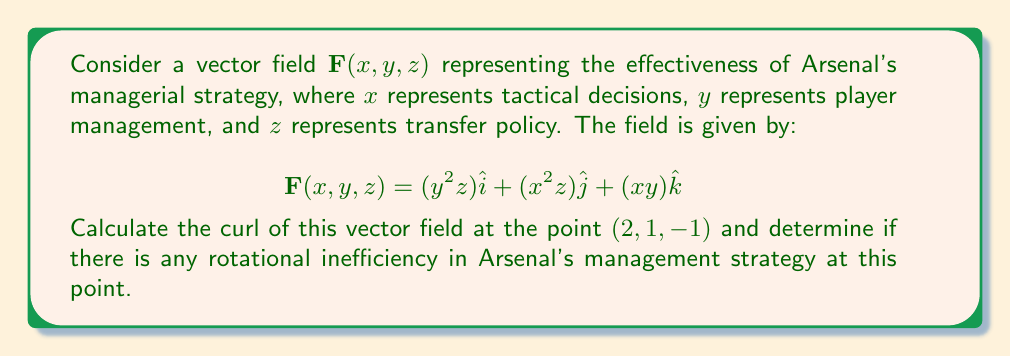Provide a solution to this math problem. To analyze the curl of the vector field, we need to follow these steps:

1) The curl of a vector field $\mathbf{F}(x, y, z) = P\hat{i} + Q\hat{j} + R\hat{k}$ is given by:

   $$\text{curl }\mathbf{F} = \nabla \times \mathbf{F} = \left(\frac{\partial R}{\partial y} - \frac{\partial Q}{\partial z}\right)\hat{i} + \left(\frac{\partial P}{\partial z} - \frac{\partial R}{\partial x}\right)\hat{j} + \left(\frac{\partial Q}{\partial x} - \frac{\partial P}{\partial y}\right)\hat{k}$$

2) For our vector field:
   $P = y^2z$, $Q = x^2z$, $R = xy$

3) Let's calculate each component:

   $\frac{\partial R}{\partial y} = x$
   $\frac{\partial Q}{\partial z} = x^2$
   $\frac{\partial P}{\partial z} = y^2$
   $\frac{\partial R}{\partial x} = y$
   $\frac{\partial Q}{\partial x} = 2xz$
   $\frac{\partial P}{\partial y} = 2yz$

4) Substituting into the curl formula:

   $$\text{curl }\mathbf{F} = (x - x^2)\hat{i} + (y^2 - y)\hat{j} + (2xz - 2yz)\hat{k}$$

5) Evaluating at the point $(2, 1, -1)$:

   $$\text{curl }\mathbf{F}(2, 1, -1) = (2 - 4)\hat{i} + (1 - 1)\hat{j} + (2(2)(-1) - 2(1)(-1))\hat{k}$$
   
   $$= -2\hat{i} + 0\hat{j} + 0\hat{k}$$

6) The non-zero curl indicates there is rotational inefficiency in Arsenal's management strategy at this point, particularly in the $x$ (tactical decisions) direction.
Answer: $-2\hat{i}$ 